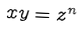<formula> <loc_0><loc_0><loc_500><loc_500>x y = z ^ { n }</formula> 